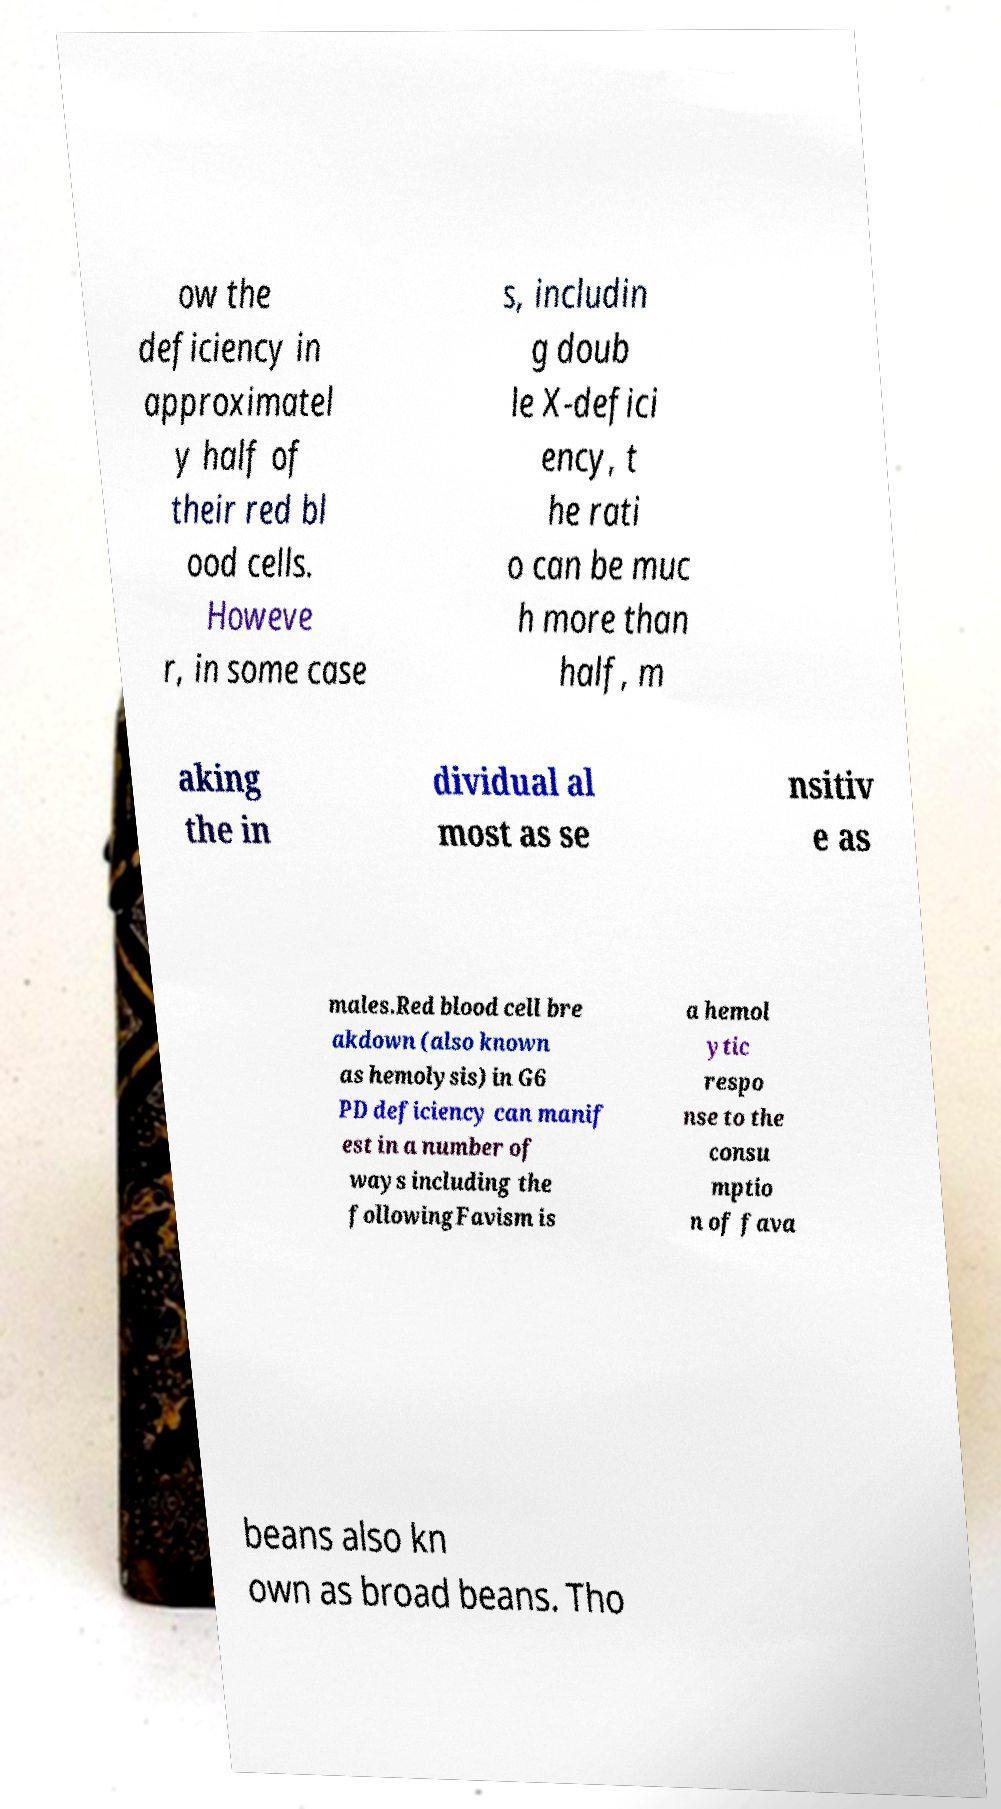What messages or text are displayed in this image? I need them in a readable, typed format. ow the deficiency in approximatel y half of their red bl ood cells. Howeve r, in some case s, includin g doub le X-defici ency, t he rati o can be muc h more than half, m aking the in dividual al most as se nsitiv e as males.Red blood cell bre akdown (also known as hemolysis) in G6 PD deficiency can manif est in a number of ways including the followingFavism is a hemol ytic respo nse to the consu mptio n of fava beans also kn own as broad beans. Tho 